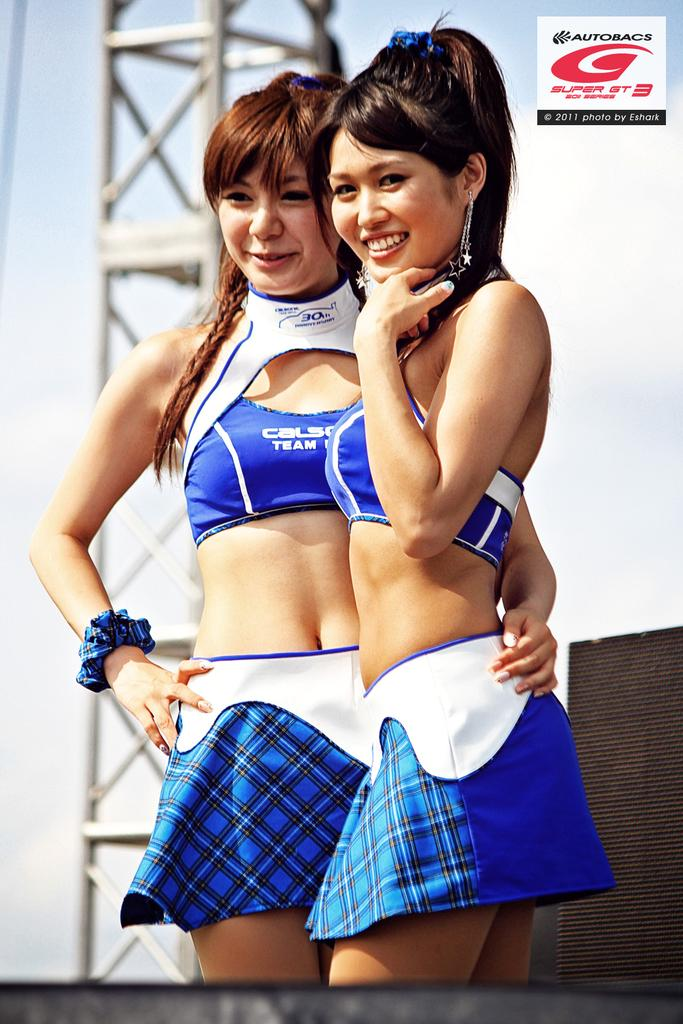<image>
Give a short and clear explanation of the subsequent image. the photo of girls is taken by Eshark dated 2011 